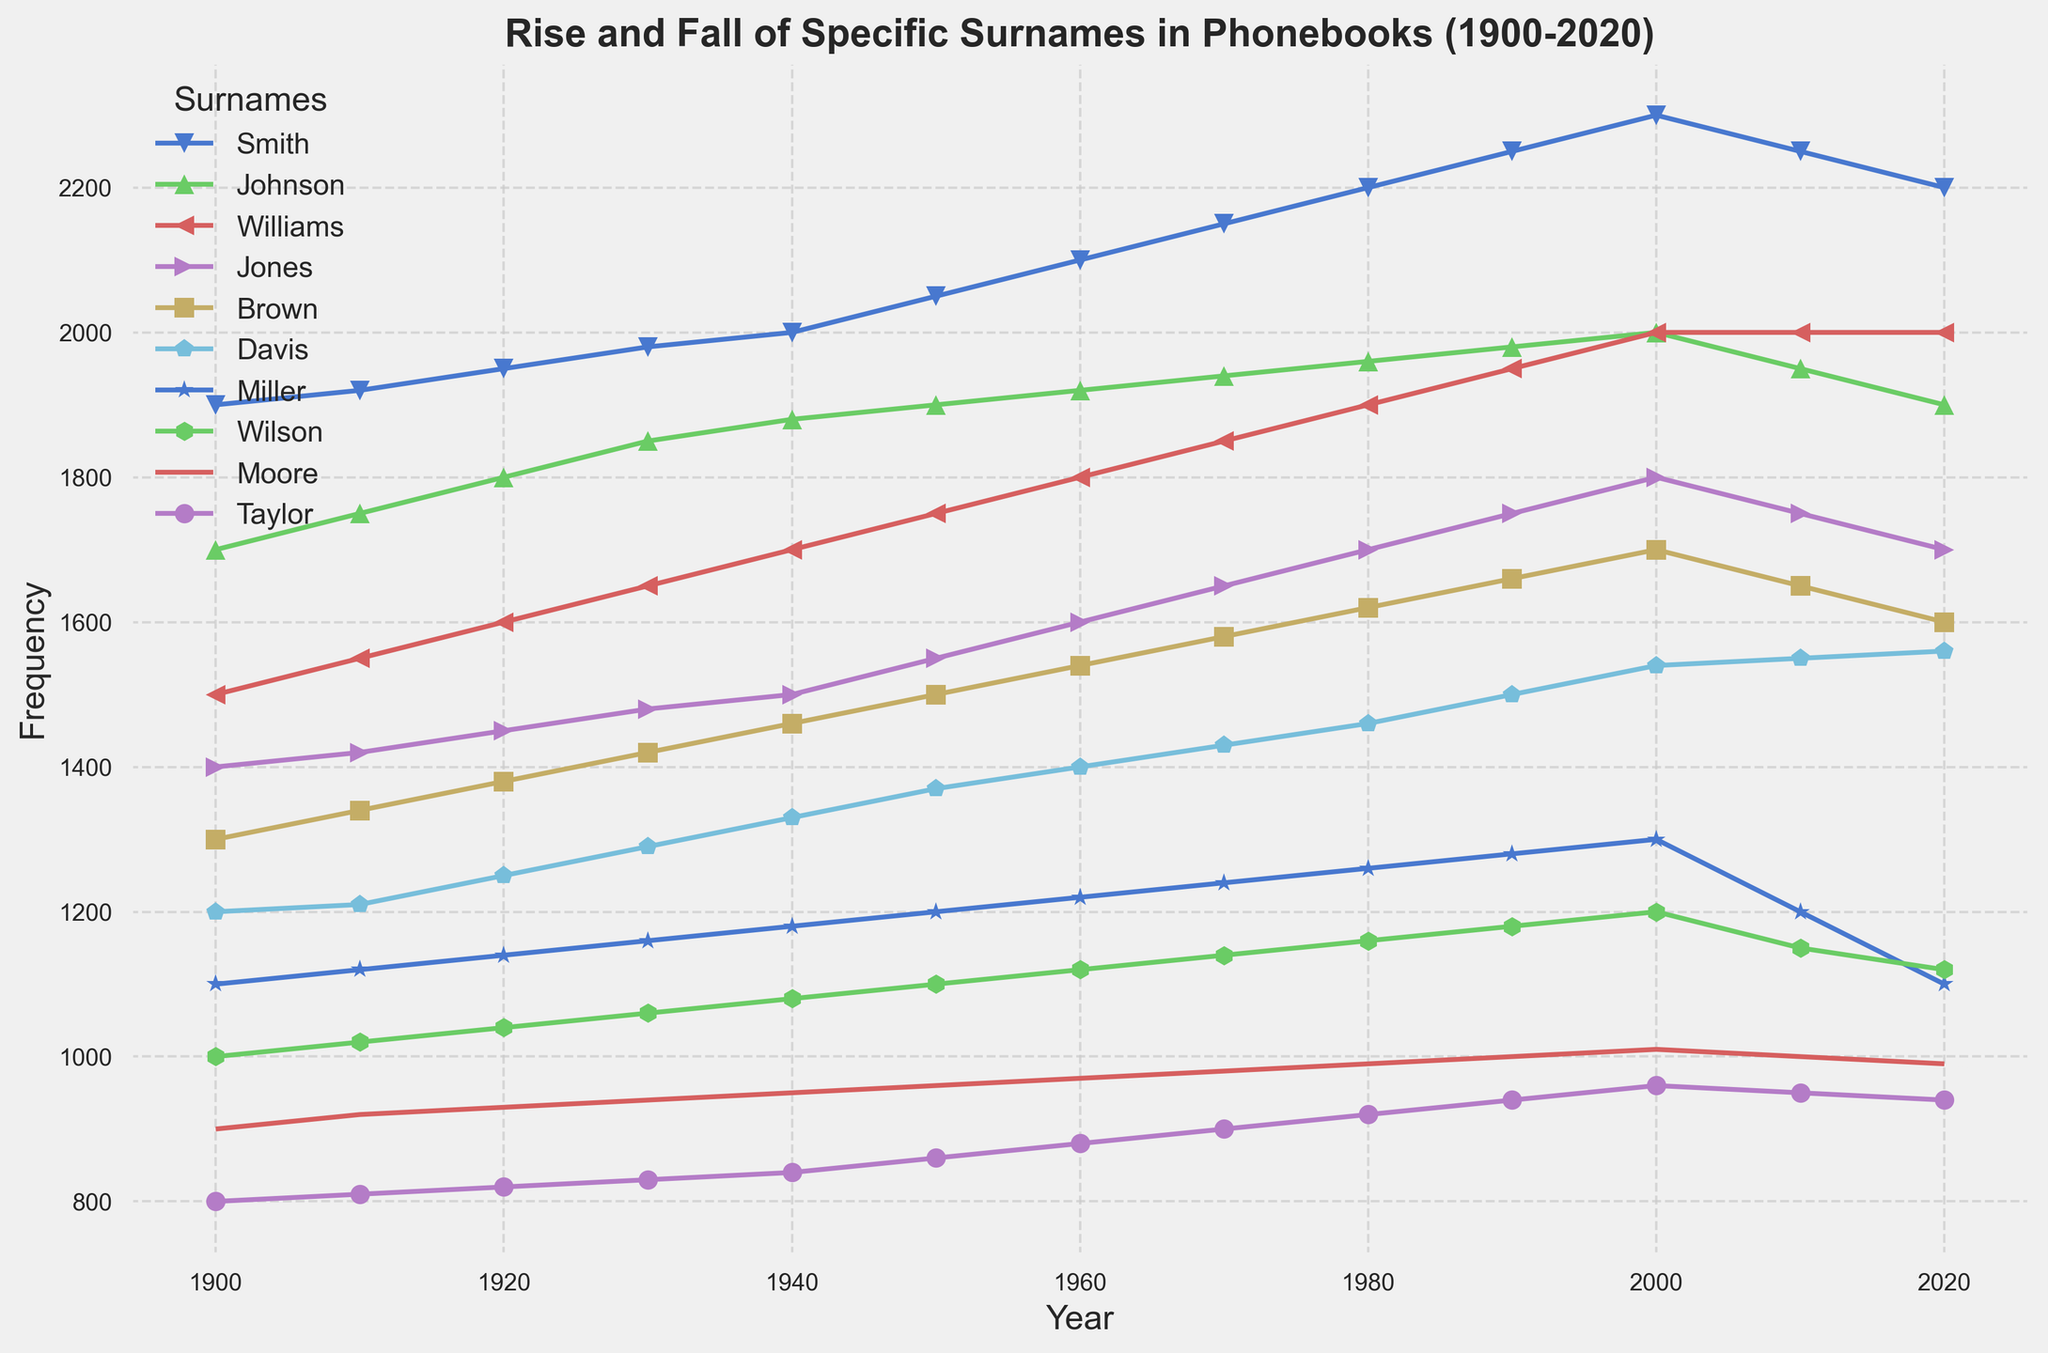What surname had the highest frequency in 1950? Looking at the chart for the year 1950, we see that "Smith" has the highest frequency among all surnames.
Answer: Smith Which surname had the largest increase in frequency from 1900 to 2000? To determine the surname with the largest increase, we need to compute the difference between the frequencies in 2000 and 1900 for each surname. By visually inspecting the plot and calculating briefly, we find that "Smith" has the largest increase.
Answer: Smith Between which years did the surname "Taylor" experience the greatest increase in frequency? By inspecting the trajectory of "Taylor" on the chart, we identify that the greatest increase in frequency happened between 1950 and 1960.
Answer: 1950 and 1960 How did the frequency of "Moore" change from 2010 to 2020? We can see that the frequency of "Moore" decreased slightly from 1010 in 2010 to 990 in 2020.
Answer: Decreased Which surnames had a declining frequency after reaching their peak values? By inspecting the trends, we see that "Smith," "Johnson," and "Moore" had their peak values in the 2000s and showed a decline afterward.
Answer: Smith, Johnson, Moore Did any surname frequencies remain constant after a certain year? From the chart, we can observe that the frequency of "Williams" remained constant at 2000 after the year 2000.
Answer: Williams What is the difference in frequency between the surnames "Wilson" and "Brown" in 2020? The frequency of "Wilson" in 2020 is 1120 and the frequency of "Brown" in 2020 is 1600. The difference is 1600 - 1120 = 480.
Answer: 480 Which surname shows the most consistent growth over the 120-year period? By closely examining the trends, "Johnson" shows the most consistent growth without significant declines.
Answer: Johnson What is the average frequency of "Davis" over the observed years? Adding frequencies for "Davis" across years and then dividing by the number of years: (1200+1210+1250+1290+1330+1370+1400+1430+1460+1500+1540+1550+1560)/13 = 1390.
Answer: 1390 